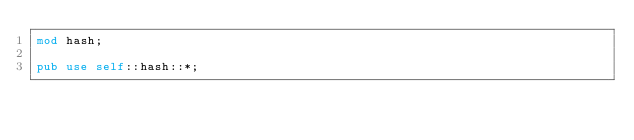Convert code to text. <code><loc_0><loc_0><loc_500><loc_500><_Rust_>mod hash;

pub use self::hash::*;</code> 